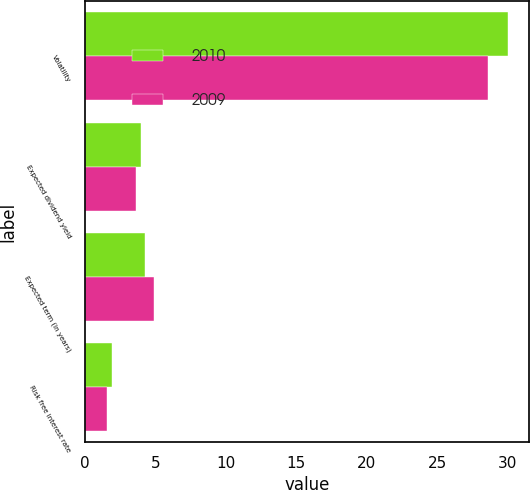<chart> <loc_0><loc_0><loc_500><loc_500><stacked_bar_chart><ecel><fcel>Volatility<fcel>Expected dividend yield<fcel>Expected term (in years)<fcel>Risk free interest rate<nl><fcel>2010<fcel>30<fcel>4<fcel>4.3<fcel>1.9<nl><fcel>2009<fcel>28.6<fcel>3.6<fcel>4.9<fcel>1.6<nl></chart> 